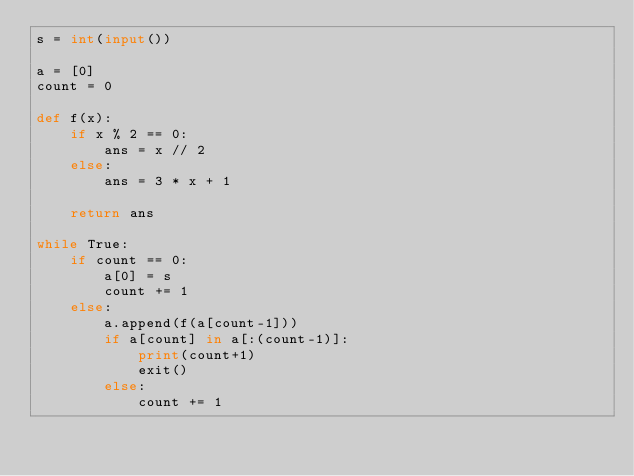Convert code to text. <code><loc_0><loc_0><loc_500><loc_500><_Python_>s = int(input())

a = [0]
count = 0

def f(x):
    if x % 2 == 0:
        ans = x // 2
    else:
        ans = 3 * x + 1

    return ans

while True:
    if count == 0:
        a[0] = s
        count += 1
    else:
        a.append(f(a[count-1]))
        if a[count] in a[:(count-1)]:
            print(count+1)
            exit()
        else:
            count += 1</code> 